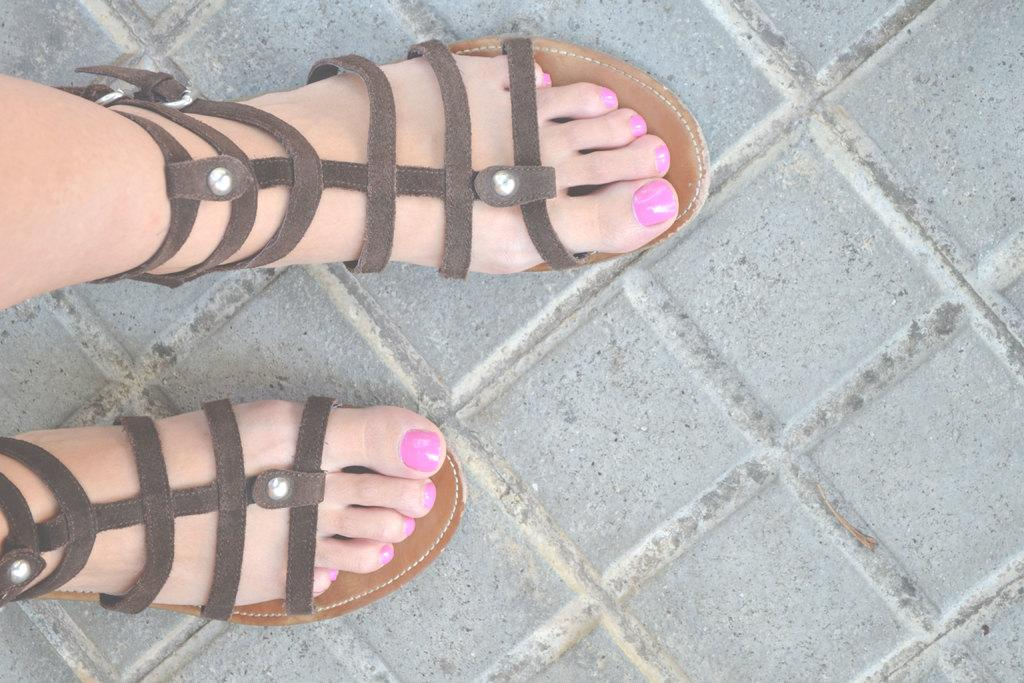What body parts of women are visible in the image? There are women's legs visible in the image. What type of footwear are the women wearing? The women are wearing sandals. What type of floor is shown in the image? The image shows a floor. What story is being told by the person holding the rake in the image? There is no person holding a rake present in the image. What type of activity might the person be engaged in with the rake in the image? There is no person or rake present in the image, so it is not possible to determine what activity they might be engaged in. 